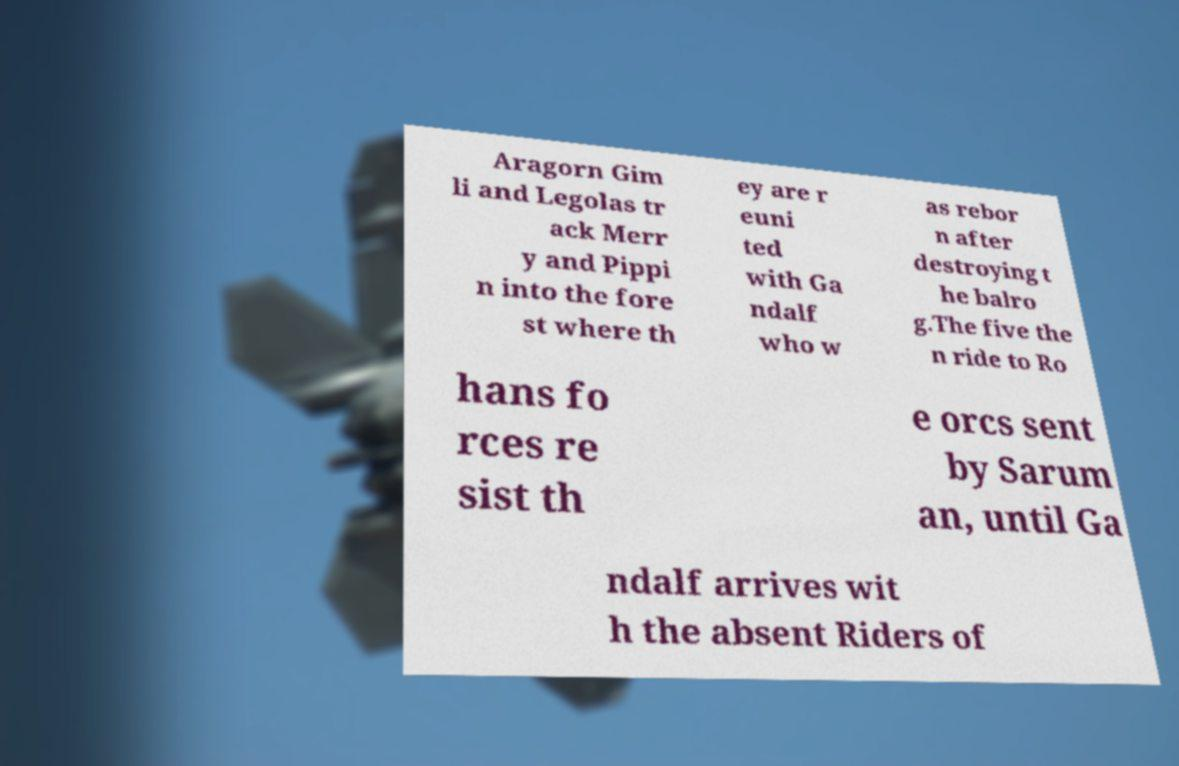Could you extract and type out the text from this image? Aragorn Gim li and Legolas tr ack Merr y and Pippi n into the fore st where th ey are r euni ted with Ga ndalf who w as rebor n after destroying t he balro g.The five the n ride to Ro hans fo rces re sist th e orcs sent by Sarum an, until Ga ndalf arrives wit h the absent Riders of 